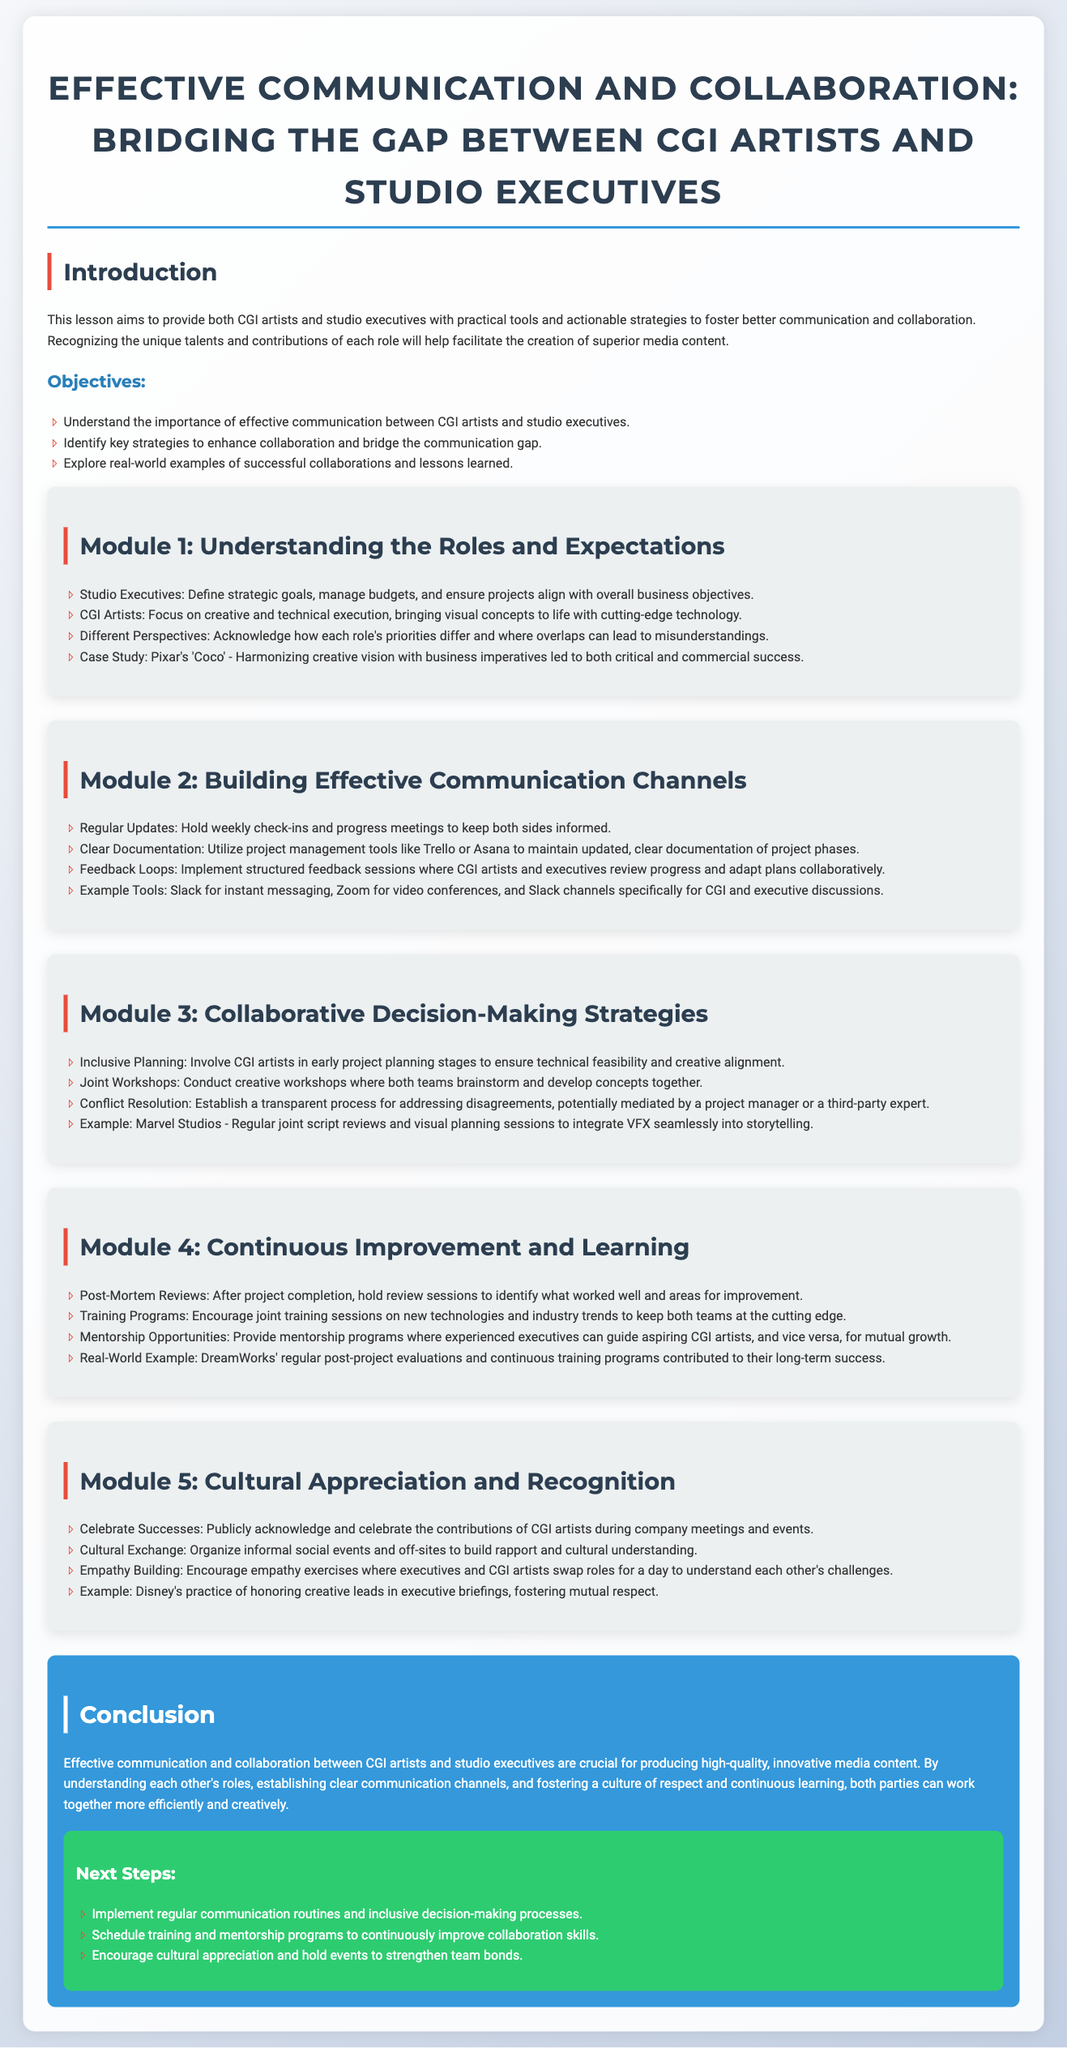What is the title of the lesson plan? The title is prominently displayed at the beginning of the document.
Answer: Effective Communication and Collaboration: Bridging the Gap Between CGI Artists and Studio Executives What are the three main objectives listed in the introduction? The objectives are specifically outlined in a bulleted list in the introduction section.
Answer: Understand the importance of effective communication, identify key strategies to enhance collaboration, explore real-world examples What case study is mentioned in Module 1? A specific case study is provided to highlight effective collaboration between roles.
Answer: Pixar's 'Coco' Which tool is suggested for instant messaging in Module 2? The tool is listed among others in the communication channel strategies.
Answer: Slack What is one example of a collaborative decision-making strategy? The strategies are detailed in Module 3 with specific examples provided.
Answer: Joint Workshops How often should check-ins be held according to Module 2? The frequency of communication is specified in the module.
Answer: Weekly What should be celebrated according to Module 5? The document describes a practice to acknowledge team contributions.
Answer: Successes What does the conclusion emphasize as crucial for media content production? The conclusion provides a key takeaway regarding collaboration.
Answer: Effective communication and collaboration What is the color of the next steps section? The background color is specified for this section in the document.
Answer: Green 